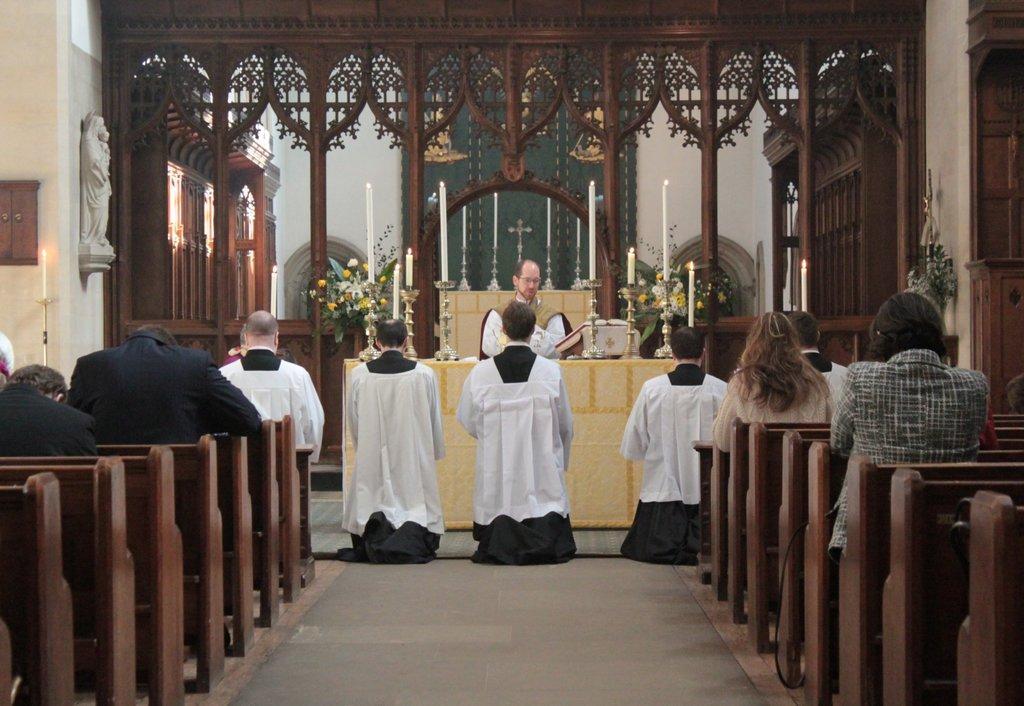Can you describe this image briefly? There is a church. People are seated on the benches. 4 people are present wearing black and white dresses. There are candles and flower bouquets. There is priest and a sculpture at the left. 